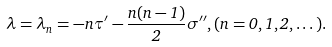<formula> <loc_0><loc_0><loc_500><loc_500>\lambda = \lambda _ { n } = - n \tau ^ { \prime } - \frac { n ( n - 1 ) } { 2 } \sigma ^ { \prime \prime } , ( n = 0 , 1 , 2 , \dots ) .</formula> 